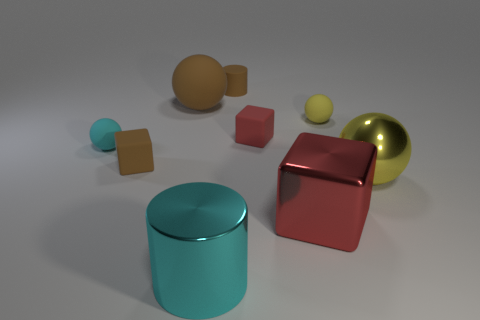There is a cyan object on the right side of the cyan object that is left of the big ball that is on the left side of the matte cylinder; what size is it?
Make the answer very short. Large. Is the number of brown cubes that are right of the brown cube greater than the number of brown matte balls to the right of the small brown cylinder?
Provide a succinct answer. No. There is a ball that is in front of the tiny yellow sphere and to the left of the cyan cylinder; what is its material?
Ensure brevity in your answer.  Rubber. Do the cyan shiny object and the big yellow shiny object have the same shape?
Your response must be concise. No. Is there any other thing that has the same size as the yellow rubber sphere?
Keep it short and to the point. Yes. What number of tiny rubber spheres are left of the large yellow shiny thing?
Give a very brief answer. 2. Do the metal cube that is on the right side of the brown cylinder and the tiny cylinder have the same size?
Keep it short and to the point. No. The other large rubber object that is the same shape as the cyan matte object is what color?
Your answer should be compact. Brown. Is there any other thing that has the same shape as the cyan metallic object?
Your answer should be very brief. Yes. What is the shape of the large metal thing that is on the left side of the matte cylinder?
Your response must be concise. Cylinder. 